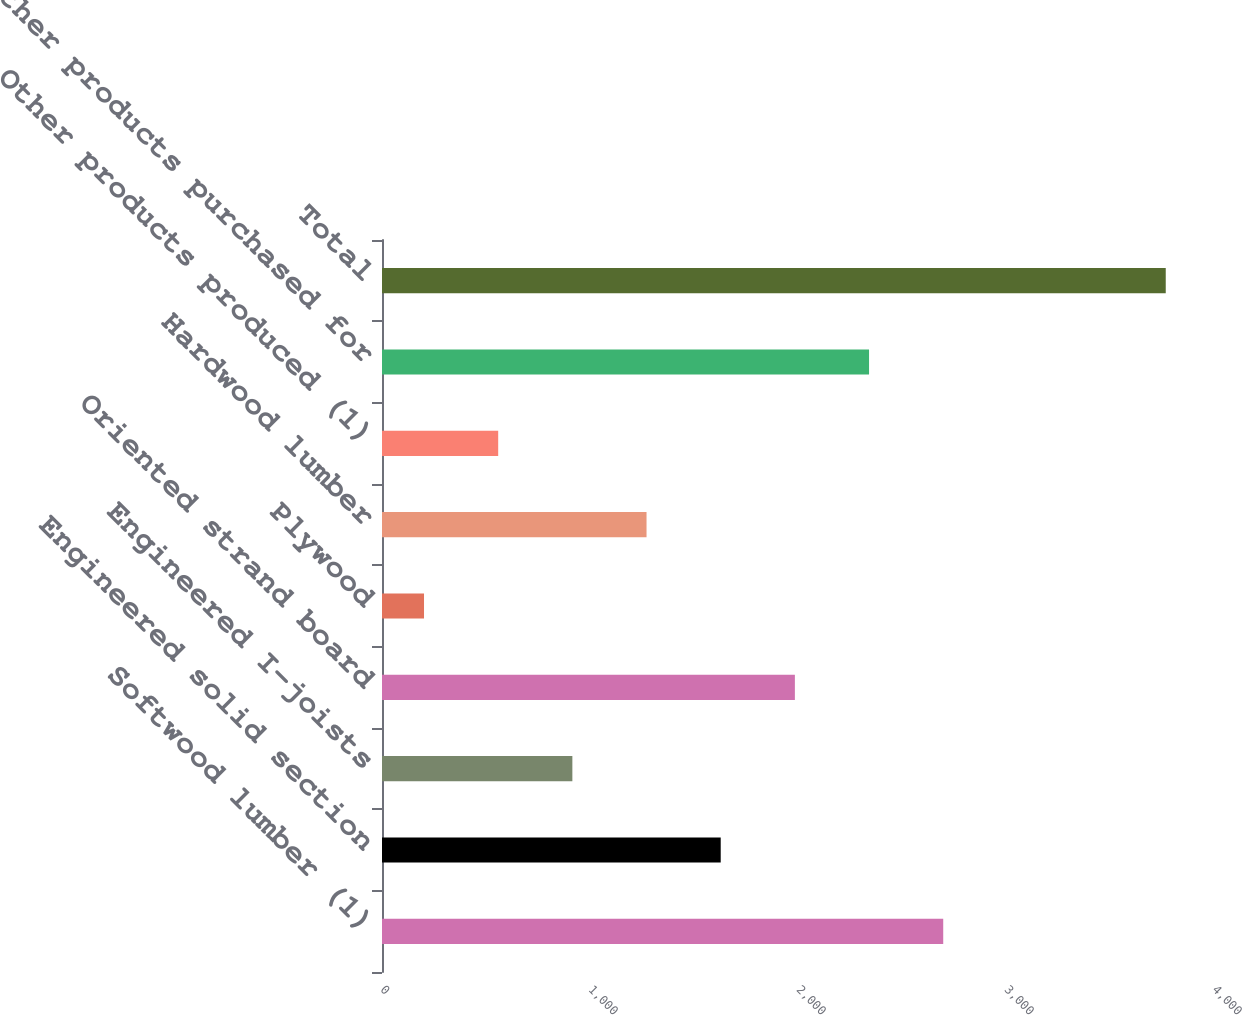<chart> <loc_0><loc_0><loc_500><loc_500><bar_chart><fcel>Softwood lumber (1)<fcel>Engineered solid section<fcel>Engineered I-joists<fcel>Oriented strand board<fcel>Plywood<fcel>Hardwood lumber<fcel>Other products produced (1)<fcel>Other products purchased for<fcel>Total<nl><fcel>2698.2<fcel>1628.4<fcel>915.2<fcel>1985<fcel>202<fcel>1271.8<fcel>558.6<fcel>2341.6<fcel>3768<nl></chart> 